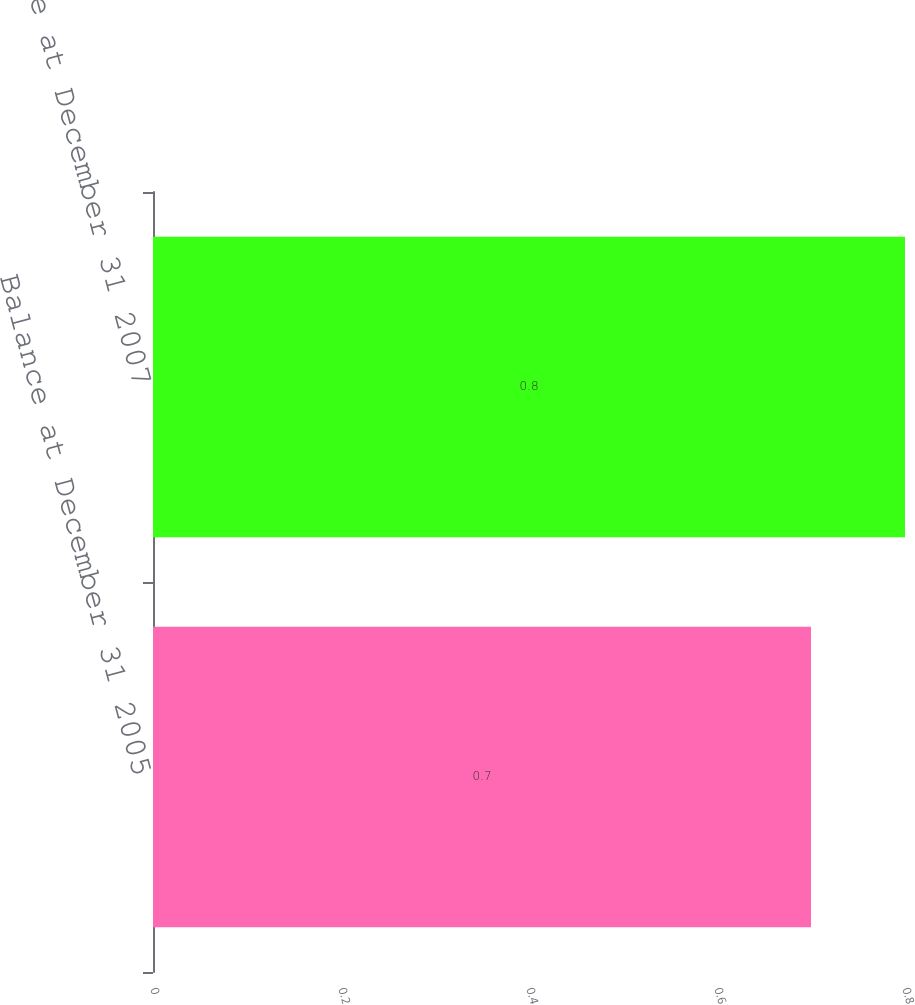Convert chart. <chart><loc_0><loc_0><loc_500><loc_500><bar_chart><fcel>Balance at December 31 2005<fcel>Balance at December 31 2007<nl><fcel>0.7<fcel>0.8<nl></chart> 